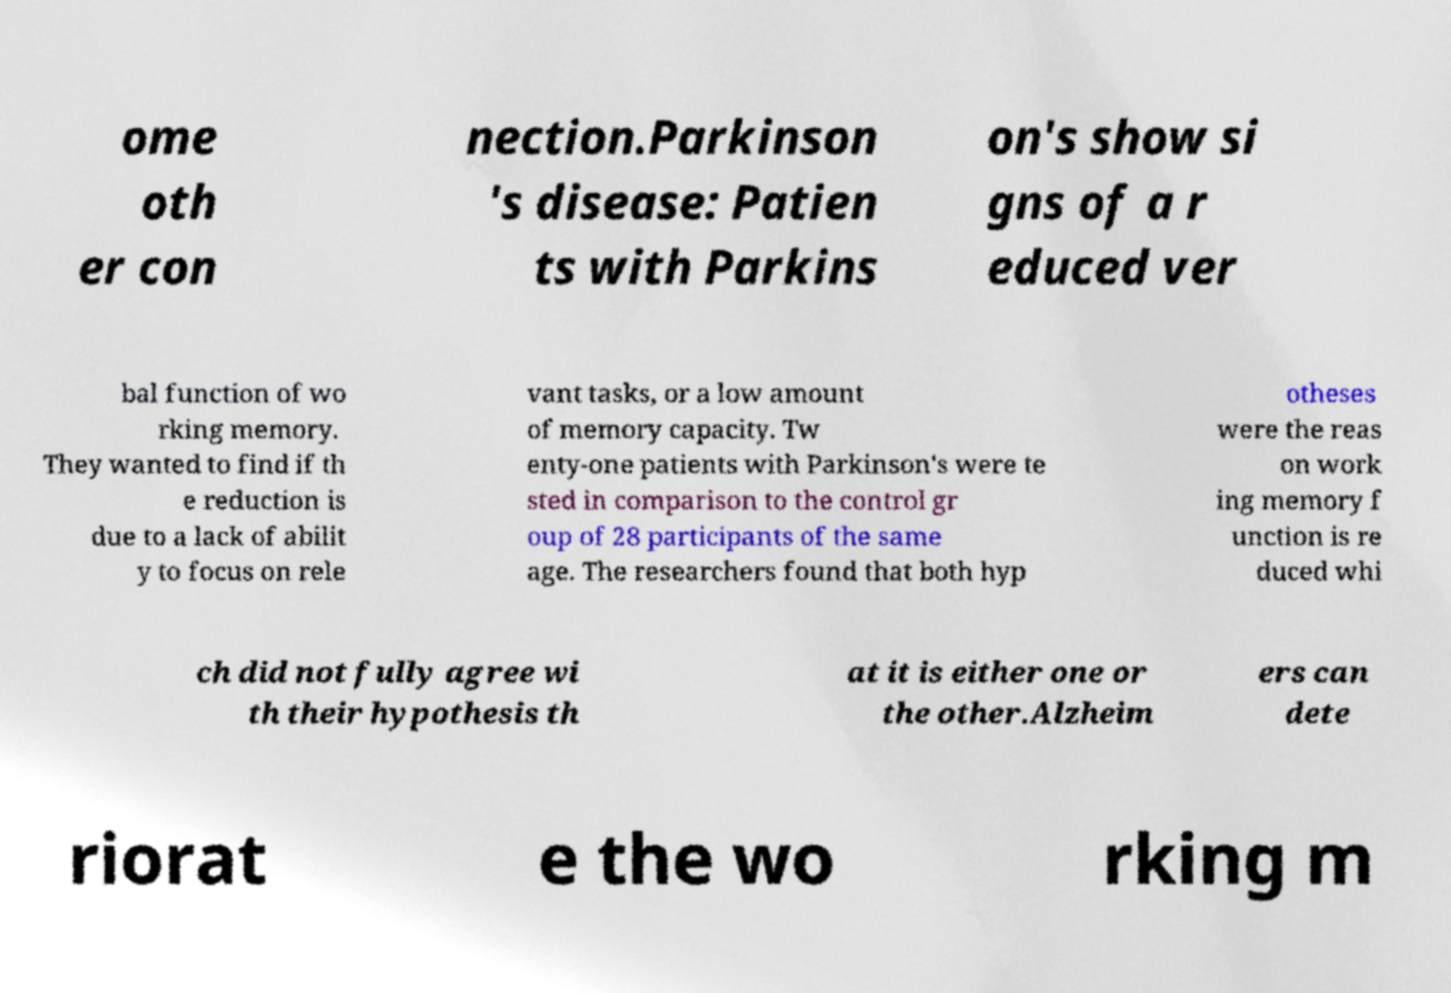I need the written content from this picture converted into text. Can you do that? ome oth er con nection.Parkinson 's disease: Patien ts with Parkins on's show si gns of a r educed ver bal function of wo rking memory. They wanted to find if th e reduction is due to a lack of abilit y to focus on rele vant tasks, or a low amount of memory capacity. Tw enty-one patients with Parkinson's were te sted in comparison to the control gr oup of 28 participants of the same age. The researchers found that both hyp otheses were the reas on work ing memory f unction is re duced whi ch did not fully agree wi th their hypothesis th at it is either one or the other.Alzheim ers can dete riorat e the wo rking m 